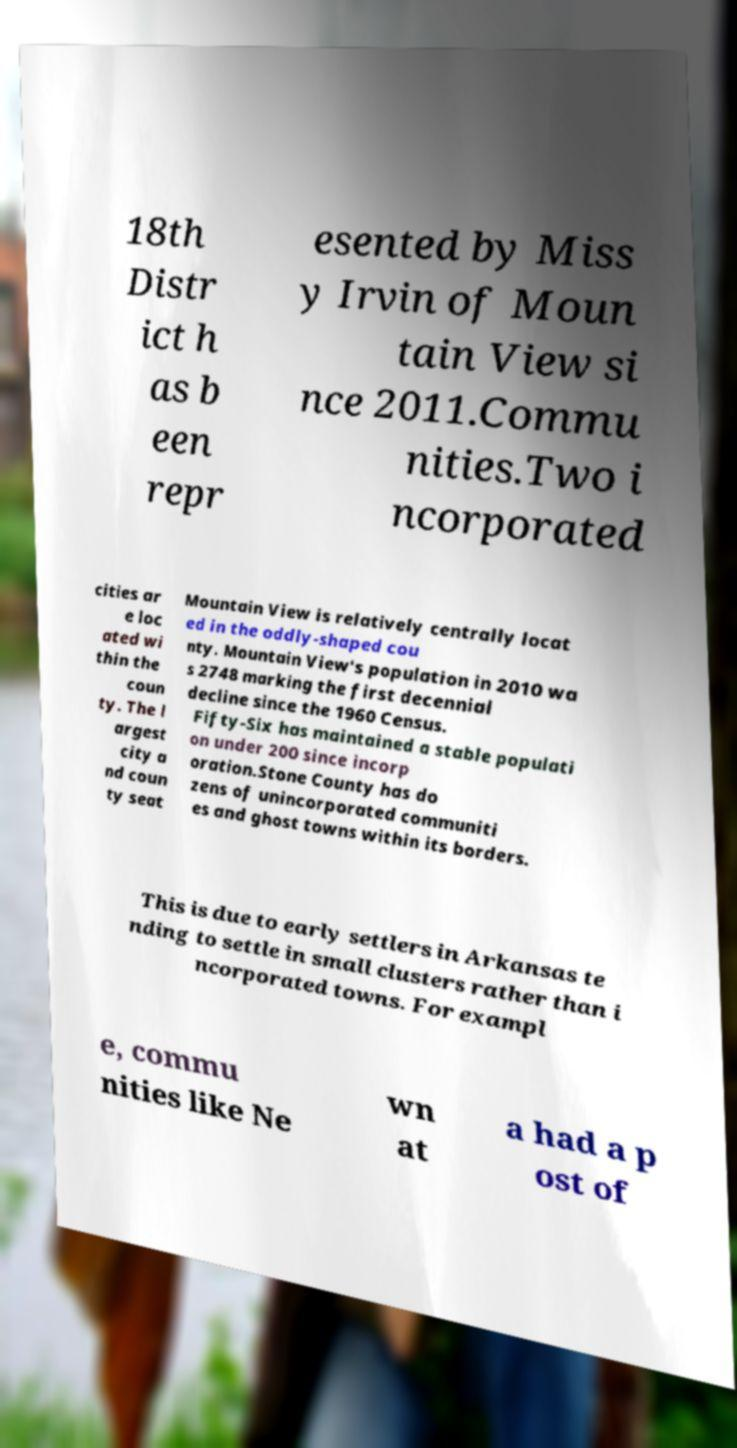Can you accurately transcribe the text from the provided image for me? 18th Distr ict h as b een repr esented by Miss y Irvin of Moun tain View si nce 2011.Commu nities.Two i ncorporated cities ar e loc ated wi thin the coun ty. The l argest city a nd coun ty seat Mountain View is relatively centrally locat ed in the oddly-shaped cou nty. Mountain View's population in 2010 wa s 2748 marking the first decennial decline since the 1960 Census. Fifty-Six has maintained a stable populati on under 200 since incorp oration.Stone County has do zens of unincorporated communiti es and ghost towns within its borders. This is due to early settlers in Arkansas te nding to settle in small clusters rather than i ncorporated towns. For exampl e, commu nities like Ne wn at a had a p ost of 